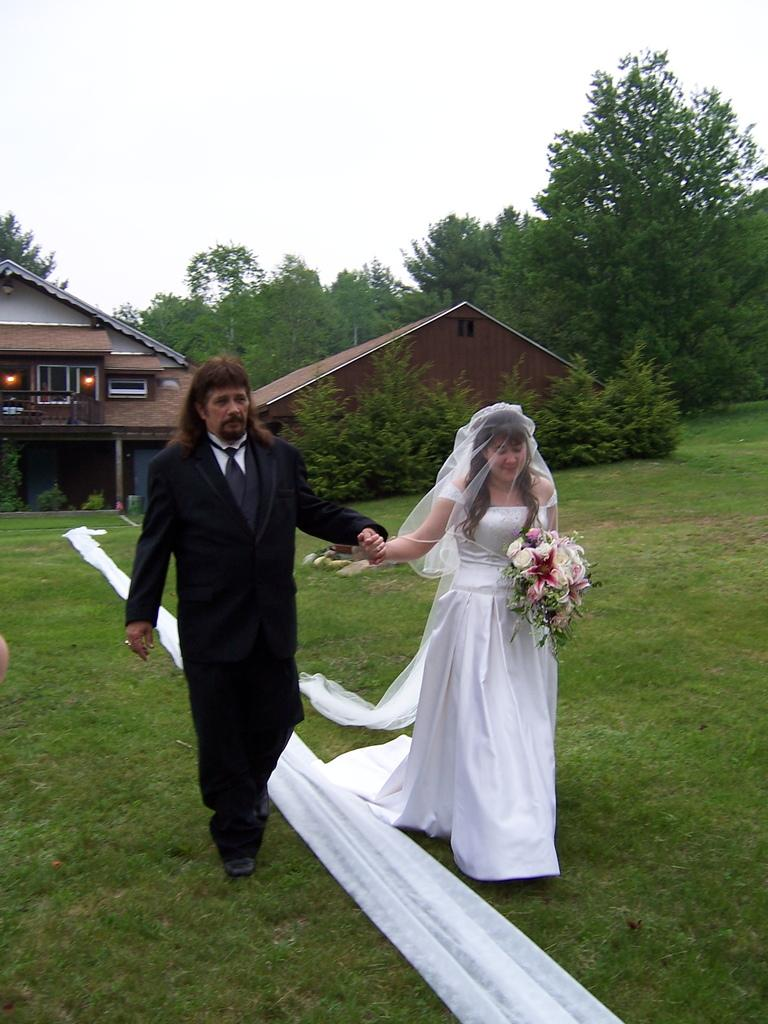Who is present in the image? There is a man and a woman in the image. What is the woman holding? The woman is holding flowers. What are the man and woman doing in the image? The man and woman are walking on the ground. What can be seen in the background of the image? There are houses, trees, and the sky visible in the background of the image. What type of pet is the woman holding in the image? There is no pet visible in the image; the woman is holding flowers. Who is the expert in the image? There is no expert mentioned or depicted in the image. 